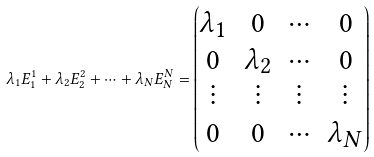<formula> <loc_0><loc_0><loc_500><loc_500>\lambda _ { 1 } E _ { 1 } ^ { 1 } + \lambda _ { 2 } E _ { 2 } ^ { 2 } + \cdots + \lambda _ { N } E _ { N } ^ { N } = \begin{pmatrix} \lambda _ { 1 } & 0 & \cdots & 0 \\ 0 & \lambda _ { 2 } & \cdots & 0 \\ \vdots & \vdots & \vdots & \vdots \\ 0 & 0 & \cdots & \lambda _ { N } \end{pmatrix}</formula> 